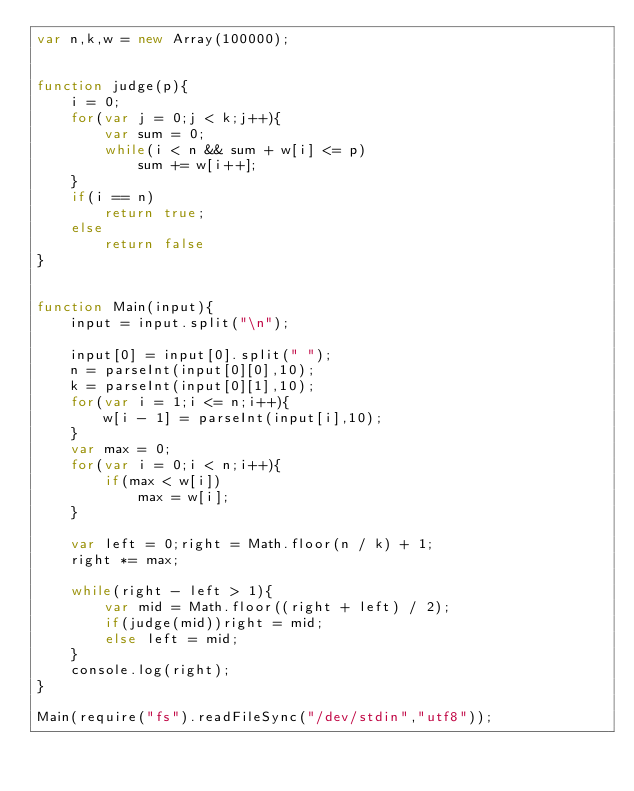<code> <loc_0><loc_0><loc_500><loc_500><_JavaScript_>var n,k,w = new Array(100000);


function judge(p){
    i = 0;
    for(var j = 0;j < k;j++){
        var sum = 0;
        while(i < n && sum + w[i] <= p)
            sum += w[i++];
    }
    if(i == n)
        return true;
    else
        return false
}


function Main(input){
    input = input.split("\n");

    input[0] = input[0].split(" ");
    n = parseInt(input[0][0],10);
    k = parseInt(input[0][1],10);
    for(var i = 1;i <= n;i++){
        w[i - 1] = parseInt(input[i],10);
    }
    var max = 0;
    for(var i = 0;i < n;i++){
        if(max < w[i])
            max = w[i];
    }

    var left = 0;right = Math.floor(n / k) + 1;
    right *= max;

    while(right - left > 1){
        var mid = Math.floor((right + left) / 2);
        if(judge(mid))right = mid;
        else left = mid;
    }
    console.log(right);
}

Main(require("fs").readFileSync("/dev/stdin","utf8"));</code> 